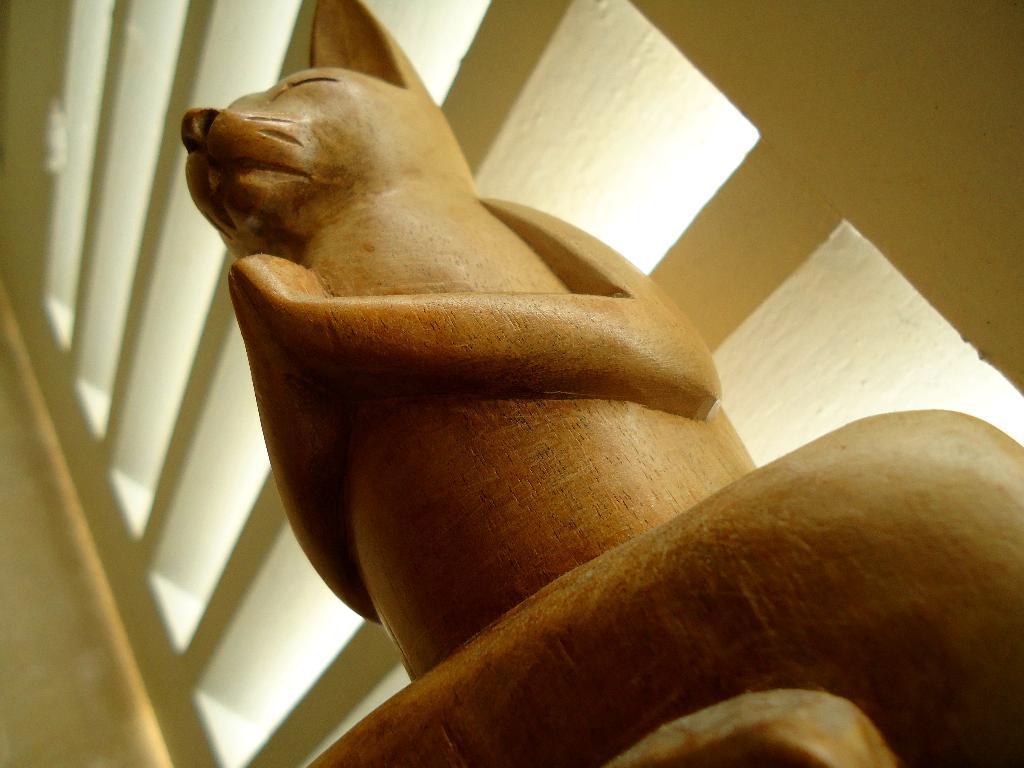In one or two sentences, can you explain what this image depicts? We can see animal statue, behind this statue we can see wall. 